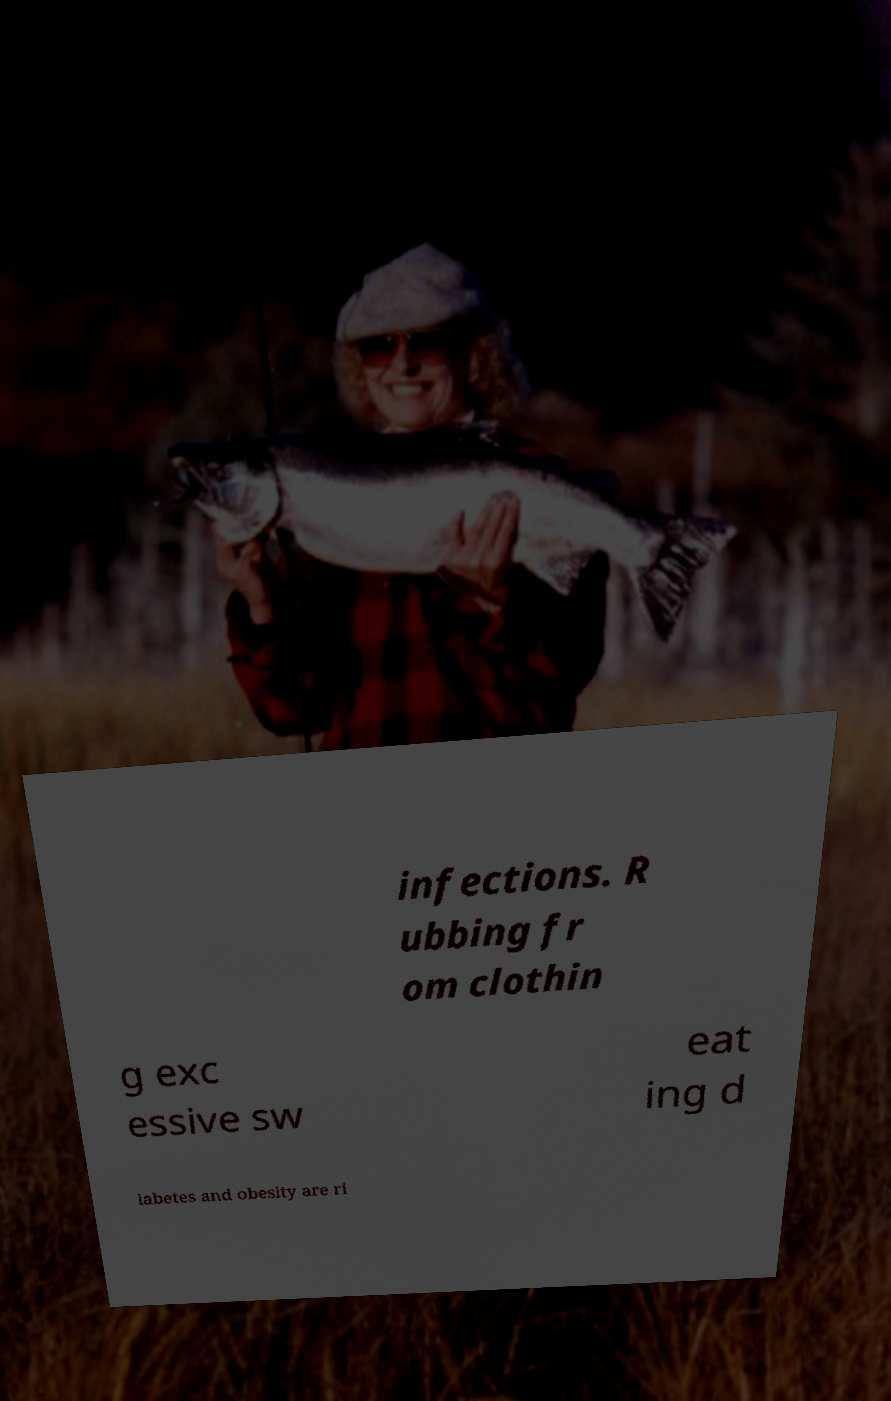There's text embedded in this image that I need extracted. Can you transcribe it verbatim? infections. R ubbing fr om clothin g exc essive sw eat ing d iabetes and obesity are ri 